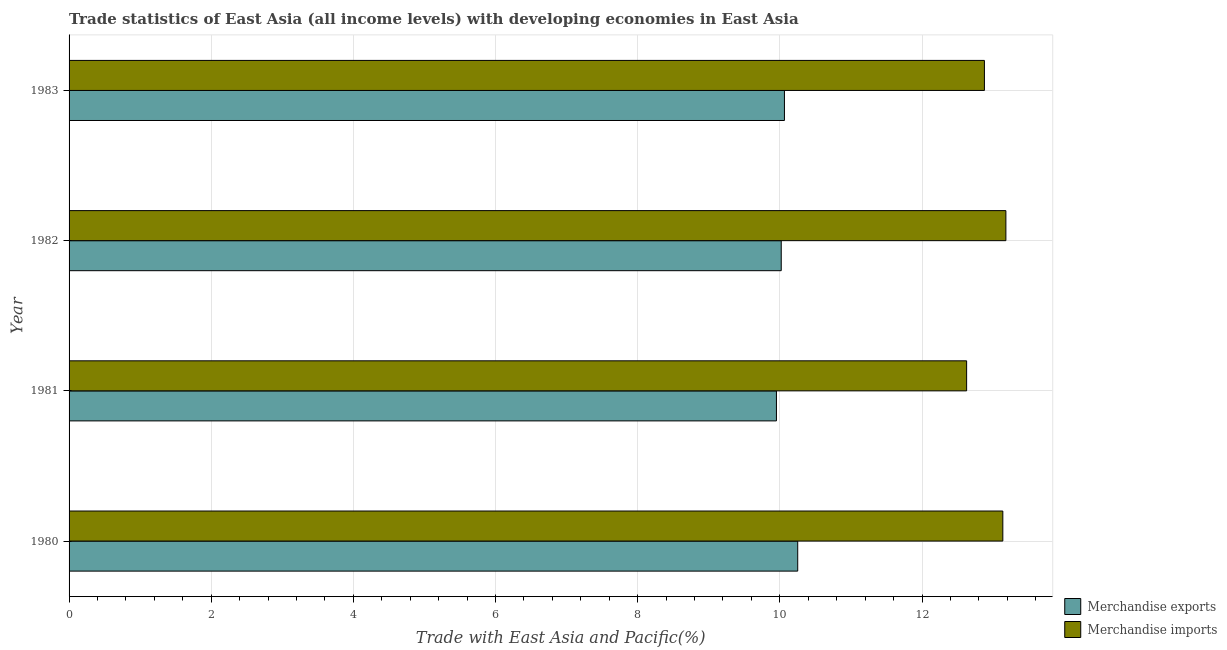How many different coloured bars are there?
Provide a succinct answer. 2. How many groups of bars are there?
Your answer should be very brief. 4. Are the number of bars per tick equal to the number of legend labels?
Give a very brief answer. Yes. Are the number of bars on each tick of the Y-axis equal?
Ensure brevity in your answer.  Yes. How many bars are there on the 4th tick from the top?
Your response must be concise. 2. How many bars are there on the 4th tick from the bottom?
Offer a very short reply. 2. What is the label of the 2nd group of bars from the top?
Offer a very short reply. 1982. What is the merchandise exports in 1981?
Offer a very short reply. 9.95. Across all years, what is the maximum merchandise exports?
Your answer should be very brief. 10.25. Across all years, what is the minimum merchandise imports?
Your response must be concise. 12.63. In which year was the merchandise imports minimum?
Your answer should be very brief. 1981. What is the total merchandise exports in the graph?
Make the answer very short. 40.29. What is the difference between the merchandise imports in 1980 and that in 1983?
Provide a succinct answer. 0.26. What is the difference between the merchandise exports in 1983 and the merchandise imports in 1982?
Your answer should be compact. -3.12. What is the average merchandise imports per year?
Keep it short and to the point. 12.96. In the year 1982, what is the difference between the merchandise exports and merchandise imports?
Give a very brief answer. -3.16. In how many years, is the merchandise exports greater than 8.8 %?
Offer a terse response. 4. What is the difference between the highest and the second highest merchandise exports?
Provide a succinct answer. 0.19. What is the difference between the highest and the lowest merchandise exports?
Your answer should be compact. 0.3. In how many years, is the merchandise exports greater than the average merchandise exports taken over all years?
Keep it short and to the point. 1. Is the sum of the merchandise exports in 1980 and 1981 greater than the maximum merchandise imports across all years?
Keep it short and to the point. Yes. How many bars are there?
Provide a short and direct response. 8. Are the values on the major ticks of X-axis written in scientific E-notation?
Provide a short and direct response. No. Does the graph contain any zero values?
Ensure brevity in your answer.  No. How are the legend labels stacked?
Your answer should be very brief. Vertical. What is the title of the graph?
Offer a very short reply. Trade statistics of East Asia (all income levels) with developing economies in East Asia. Does "% of GNI" appear as one of the legend labels in the graph?
Your answer should be compact. No. What is the label or title of the X-axis?
Provide a succinct answer. Trade with East Asia and Pacific(%). What is the label or title of the Y-axis?
Offer a terse response. Year. What is the Trade with East Asia and Pacific(%) of Merchandise exports in 1980?
Provide a short and direct response. 10.25. What is the Trade with East Asia and Pacific(%) in Merchandise imports in 1980?
Ensure brevity in your answer.  13.14. What is the Trade with East Asia and Pacific(%) in Merchandise exports in 1981?
Your response must be concise. 9.95. What is the Trade with East Asia and Pacific(%) of Merchandise imports in 1981?
Your response must be concise. 12.63. What is the Trade with East Asia and Pacific(%) in Merchandise exports in 1982?
Your answer should be very brief. 10.02. What is the Trade with East Asia and Pacific(%) of Merchandise imports in 1982?
Your answer should be very brief. 13.18. What is the Trade with East Asia and Pacific(%) of Merchandise exports in 1983?
Keep it short and to the point. 10.06. What is the Trade with East Asia and Pacific(%) of Merchandise imports in 1983?
Provide a short and direct response. 12.88. Across all years, what is the maximum Trade with East Asia and Pacific(%) in Merchandise exports?
Give a very brief answer. 10.25. Across all years, what is the maximum Trade with East Asia and Pacific(%) in Merchandise imports?
Your answer should be very brief. 13.18. Across all years, what is the minimum Trade with East Asia and Pacific(%) in Merchandise exports?
Your response must be concise. 9.95. Across all years, what is the minimum Trade with East Asia and Pacific(%) of Merchandise imports?
Your response must be concise. 12.63. What is the total Trade with East Asia and Pacific(%) in Merchandise exports in the graph?
Keep it short and to the point. 40.29. What is the total Trade with East Asia and Pacific(%) in Merchandise imports in the graph?
Make the answer very short. 51.82. What is the difference between the Trade with East Asia and Pacific(%) in Merchandise exports in 1980 and that in 1981?
Make the answer very short. 0.3. What is the difference between the Trade with East Asia and Pacific(%) in Merchandise imports in 1980 and that in 1981?
Give a very brief answer. 0.51. What is the difference between the Trade with East Asia and Pacific(%) of Merchandise exports in 1980 and that in 1982?
Give a very brief answer. 0.23. What is the difference between the Trade with East Asia and Pacific(%) of Merchandise imports in 1980 and that in 1982?
Give a very brief answer. -0.04. What is the difference between the Trade with East Asia and Pacific(%) of Merchandise exports in 1980 and that in 1983?
Give a very brief answer. 0.19. What is the difference between the Trade with East Asia and Pacific(%) of Merchandise imports in 1980 and that in 1983?
Offer a very short reply. 0.26. What is the difference between the Trade with East Asia and Pacific(%) of Merchandise exports in 1981 and that in 1982?
Offer a terse response. -0.07. What is the difference between the Trade with East Asia and Pacific(%) in Merchandise imports in 1981 and that in 1982?
Offer a terse response. -0.55. What is the difference between the Trade with East Asia and Pacific(%) of Merchandise exports in 1981 and that in 1983?
Offer a very short reply. -0.11. What is the difference between the Trade with East Asia and Pacific(%) of Merchandise imports in 1981 and that in 1983?
Provide a succinct answer. -0.25. What is the difference between the Trade with East Asia and Pacific(%) in Merchandise exports in 1982 and that in 1983?
Your answer should be compact. -0.05. What is the difference between the Trade with East Asia and Pacific(%) of Merchandise imports in 1982 and that in 1983?
Make the answer very short. 0.3. What is the difference between the Trade with East Asia and Pacific(%) in Merchandise exports in 1980 and the Trade with East Asia and Pacific(%) in Merchandise imports in 1981?
Provide a short and direct response. -2.38. What is the difference between the Trade with East Asia and Pacific(%) in Merchandise exports in 1980 and the Trade with East Asia and Pacific(%) in Merchandise imports in 1982?
Give a very brief answer. -2.93. What is the difference between the Trade with East Asia and Pacific(%) of Merchandise exports in 1980 and the Trade with East Asia and Pacific(%) of Merchandise imports in 1983?
Your answer should be compact. -2.63. What is the difference between the Trade with East Asia and Pacific(%) in Merchandise exports in 1981 and the Trade with East Asia and Pacific(%) in Merchandise imports in 1982?
Make the answer very short. -3.23. What is the difference between the Trade with East Asia and Pacific(%) of Merchandise exports in 1981 and the Trade with East Asia and Pacific(%) of Merchandise imports in 1983?
Give a very brief answer. -2.93. What is the difference between the Trade with East Asia and Pacific(%) in Merchandise exports in 1982 and the Trade with East Asia and Pacific(%) in Merchandise imports in 1983?
Your response must be concise. -2.86. What is the average Trade with East Asia and Pacific(%) in Merchandise exports per year?
Make the answer very short. 10.07. What is the average Trade with East Asia and Pacific(%) of Merchandise imports per year?
Give a very brief answer. 12.96. In the year 1980, what is the difference between the Trade with East Asia and Pacific(%) in Merchandise exports and Trade with East Asia and Pacific(%) in Merchandise imports?
Your answer should be very brief. -2.89. In the year 1981, what is the difference between the Trade with East Asia and Pacific(%) in Merchandise exports and Trade with East Asia and Pacific(%) in Merchandise imports?
Give a very brief answer. -2.68. In the year 1982, what is the difference between the Trade with East Asia and Pacific(%) of Merchandise exports and Trade with East Asia and Pacific(%) of Merchandise imports?
Keep it short and to the point. -3.16. In the year 1983, what is the difference between the Trade with East Asia and Pacific(%) in Merchandise exports and Trade with East Asia and Pacific(%) in Merchandise imports?
Ensure brevity in your answer.  -2.81. What is the ratio of the Trade with East Asia and Pacific(%) of Merchandise exports in 1980 to that in 1981?
Make the answer very short. 1.03. What is the ratio of the Trade with East Asia and Pacific(%) in Merchandise imports in 1980 to that in 1981?
Keep it short and to the point. 1.04. What is the ratio of the Trade with East Asia and Pacific(%) of Merchandise exports in 1980 to that in 1982?
Give a very brief answer. 1.02. What is the ratio of the Trade with East Asia and Pacific(%) in Merchandise imports in 1980 to that in 1982?
Make the answer very short. 1. What is the ratio of the Trade with East Asia and Pacific(%) in Merchandise exports in 1980 to that in 1983?
Give a very brief answer. 1.02. What is the ratio of the Trade with East Asia and Pacific(%) in Merchandise imports in 1980 to that in 1983?
Your answer should be compact. 1.02. What is the ratio of the Trade with East Asia and Pacific(%) of Merchandise imports in 1981 to that in 1982?
Offer a very short reply. 0.96. What is the ratio of the Trade with East Asia and Pacific(%) in Merchandise exports in 1981 to that in 1983?
Provide a succinct answer. 0.99. What is the ratio of the Trade with East Asia and Pacific(%) in Merchandise imports in 1981 to that in 1983?
Offer a terse response. 0.98. What is the ratio of the Trade with East Asia and Pacific(%) in Merchandise imports in 1982 to that in 1983?
Ensure brevity in your answer.  1.02. What is the difference between the highest and the second highest Trade with East Asia and Pacific(%) in Merchandise exports?
Provide a succinct answer. 0.19. What is the difference between the highest and the second highest Trade with East Asia and Pacific(%) in Merchandise imports?
Keep it short and to the point. 0.04. What is the difference between the highest and the lowest Trade with East Asia and Pacific(%) in Merchandise exports?
Give a very brief answer. 0.3. What is the difference between the highest and the lowest Trade with East Asia and Pacific(%) in Merchandise imports?
Provide a short and direct response. 0.55. 